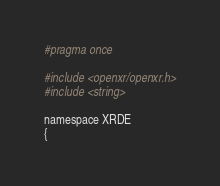Convert code to text. <code><loc_0><loc_0><loc_500><loc_500><_C_>#pragma once

#include <openxr/openxr.h>
#include <string>

namespace XRDE
{</code> 